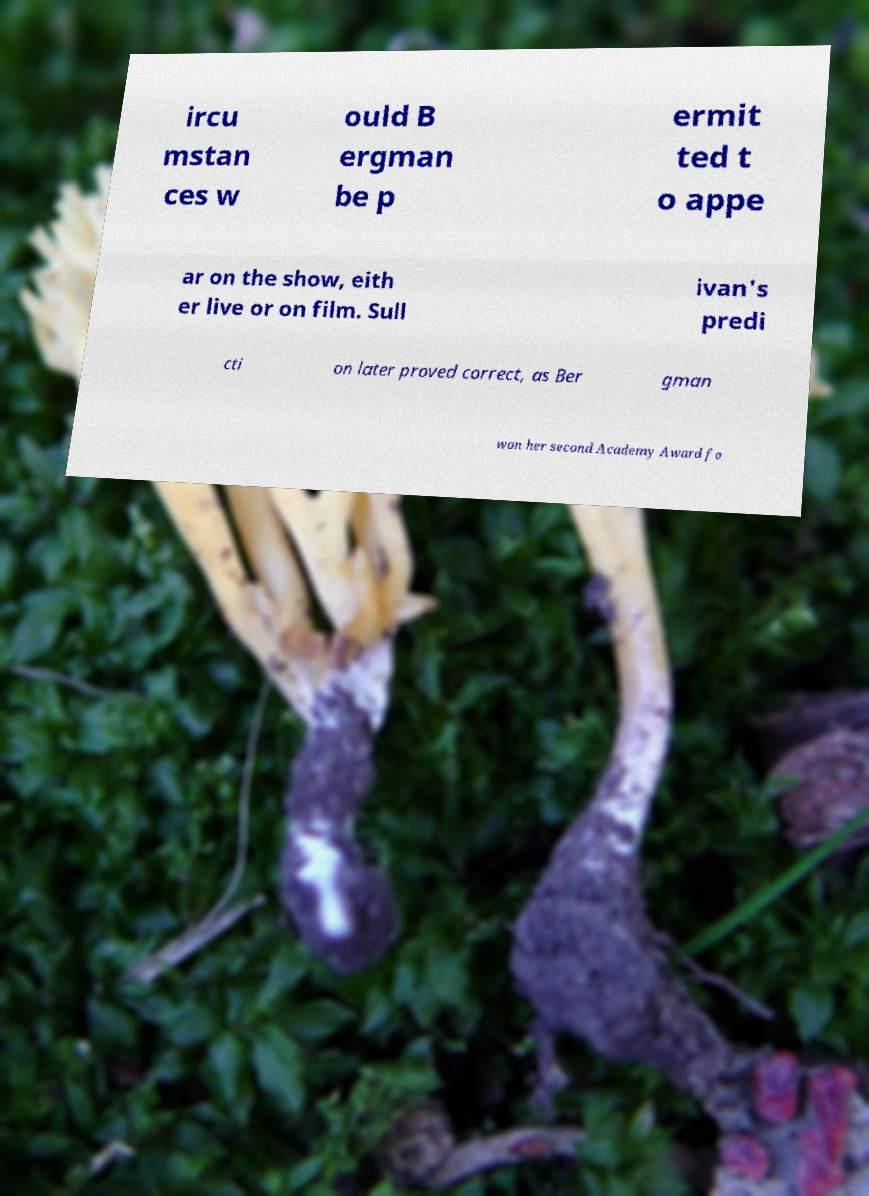For documentation purposes, I need the text within this image transcribed. Could you provide that? ircu mstan ces w ould B ergman be p ermit ted t o appe ar on the show, eith er live or on film. Sull ivan's predi cti on later proved correct, as Ber gman won her second Academy Award fo 